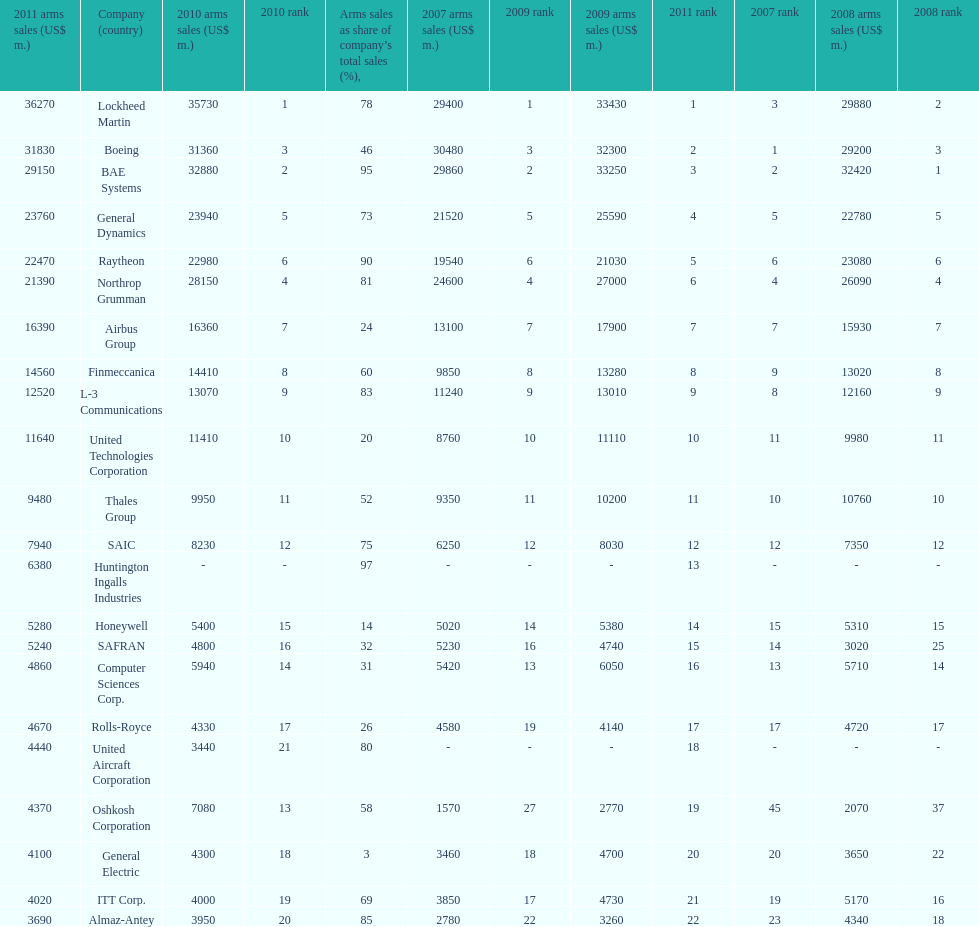What is the difference of the amount sold between boeing and general dynamics in 2007? 8960. 